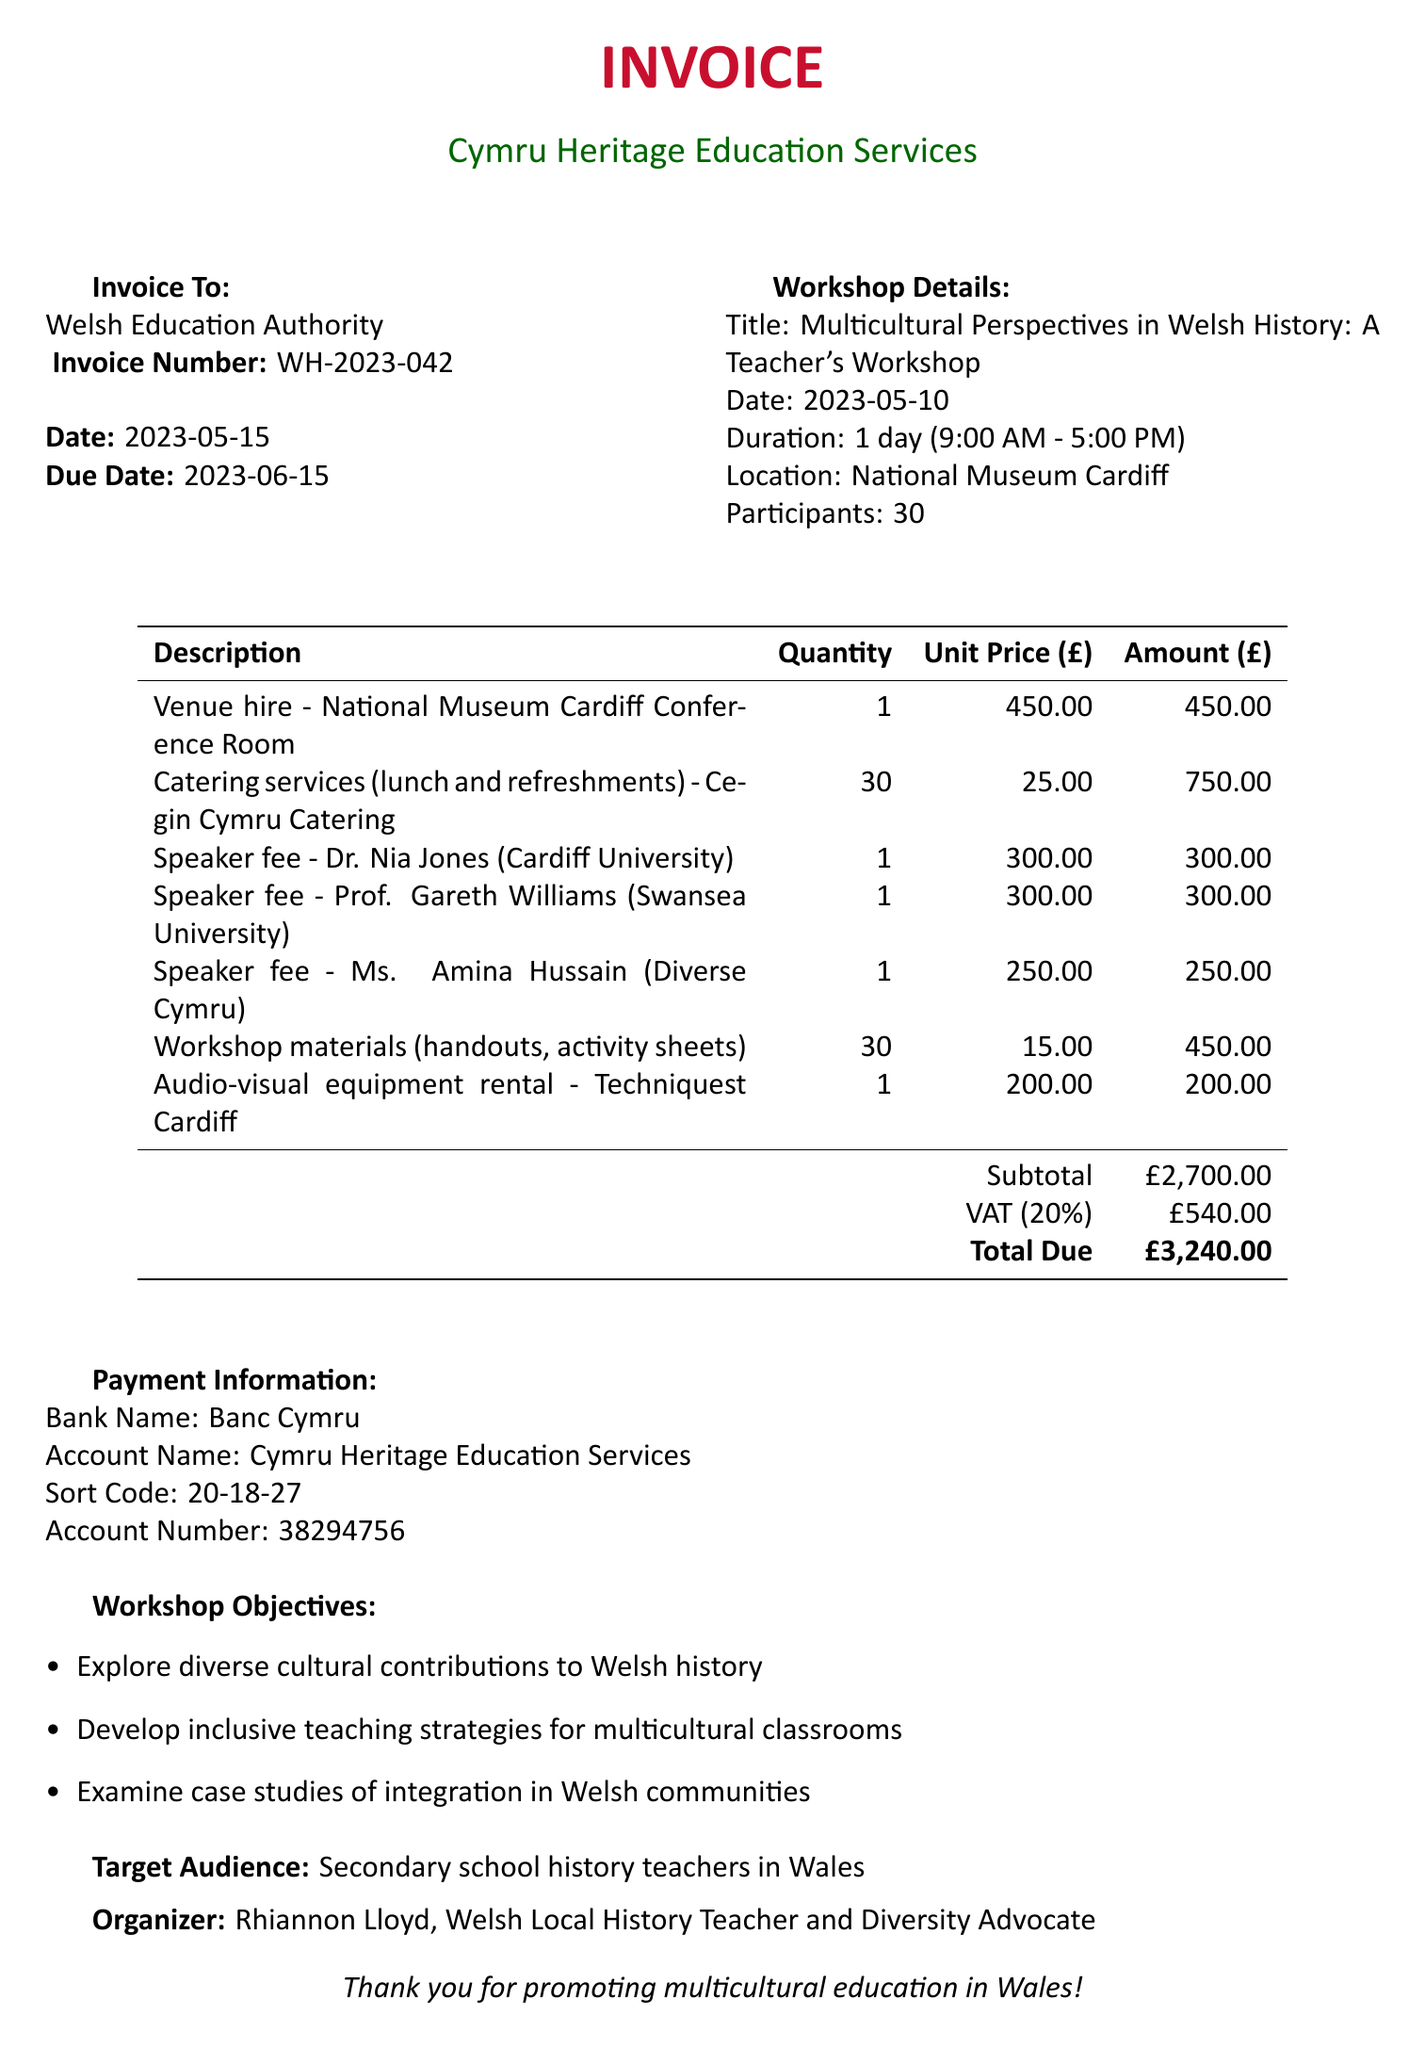What is the invoice number? The invoice number is listed in the invoice details section of the document.
Answer: WH-2023-042 What is the total due amount? The total due amount is the final figure presented in the payment summary at the end of the invoice.
Answer: £3,240.00 Who is the organizer of the workshop? The organizer's name is mentioned in the additional information section of the document.
Answer: Rhiannon Lloyd What is the date of the workshop? The date of the workshop is specified in the workshop details section of the document.
Answer: 2023-05-10 How many participants attended the workshop? The number of participants is indicated in the workshop information section.
Answer: 30 What is the unit price for the venue hire? The unit price for the venue hire can be found in the line items table of the document.
Answer: 450.00 What was one of the workshop objectives? One of the workshop objectives is provided in the additional information section of the document.
Answer: Explore diverse cultural contributions to Welsh history What services were provided by Cegin Cymru Catering? The services rendered by Cegin Cymru Catering are detailed in the line items section.
Answer: Catering services (lunch and refreshments) What is the VAT percentage applied? The VAT percentage is indicated in the total calculation section of the document.
Answer: 20% 